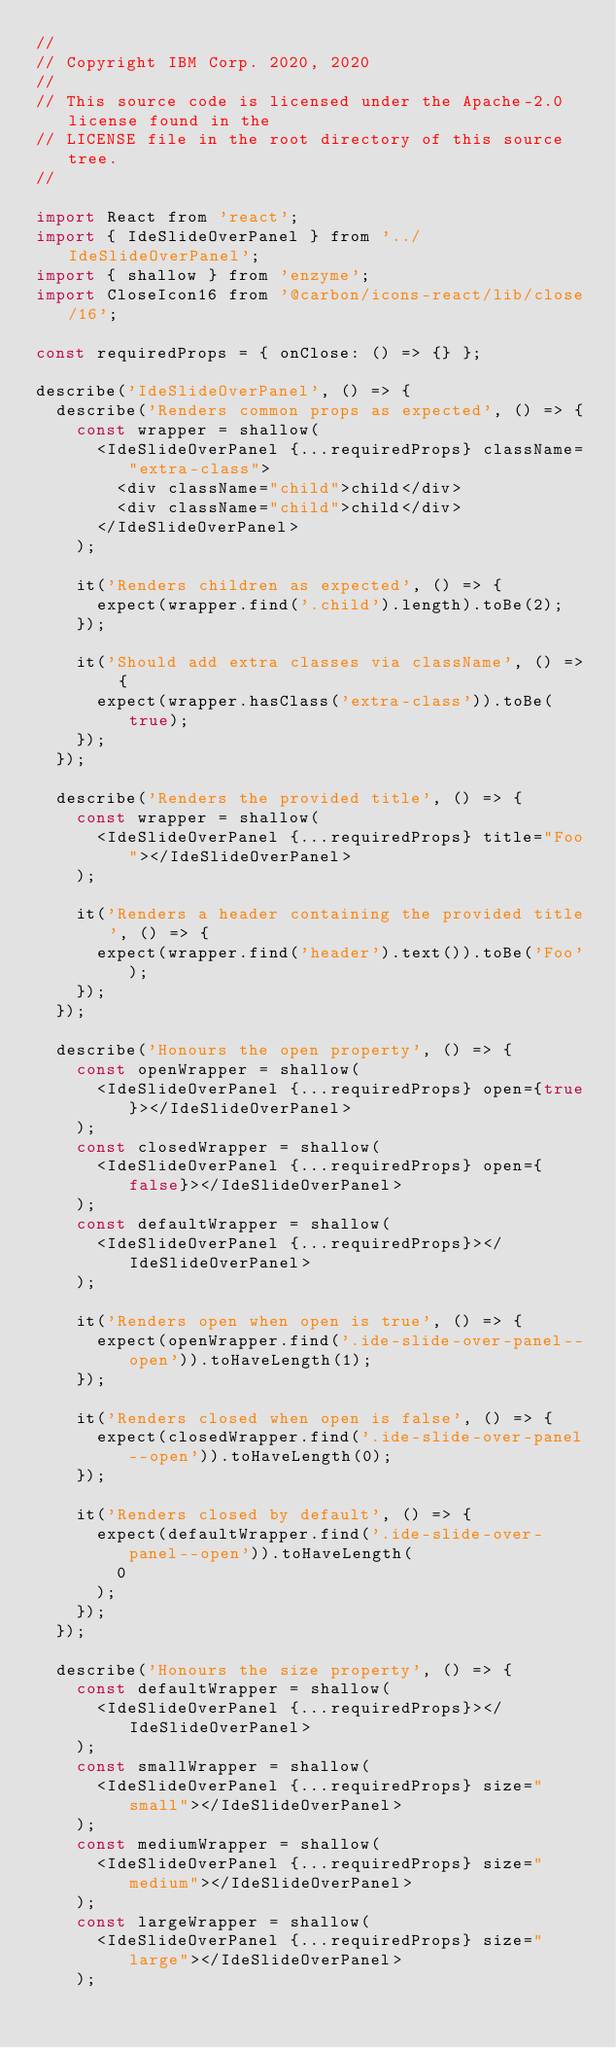Convert code to text. <code><loc_0><loc_0><loc_500><loc_500><_JavaScript_>//
// Copyright IBM Corp. 2020, 2020
//
// This source code is licensed under the Apache-2.0 license found in the
// LICENSE file in the root directory of this source tree.
//

import React from 'react';
import { IdeSlideOverPanel } from '../IdeSlideOverPanel';
import { shallow } from 'enzyme';
import CloseIcon16 from '@carbon/icons-react/lib/close/16';

const requiredProps = { onClose: () => {} };

describe('IdeSlideOverPanel', () => {
  describe('Renders common props as expected', () => {
    const wrapper = shallow(
      <IdeSlideOverPanel {...requiredProps} className="extra-class">
        <div className="child">child</div>
        <div className="child">child</div>
      </IdeSlideOverPanel>
    );

    it('Renders children as expected', () => {
      expect(wrapper.find('.child').length).toBe(2);
    });

    it('Should add extra classes via className', () => {
      expect(wrapper.hasClass('extra-class')).toBe(true);
    });
  });

  describe('Renders the provided title', () => {
    const wrapper = shallow(
      <IdeSlideOverPanel {...requiredProps} title="Foo"></IdeSlideOverPanel>
    );

    it('Renders a header containing the provided title', () => {
      expect(wrapper.find('header').text()).toBe('Foo');
    });
  });

  describe('Honours the open property', () => {
    const openWrapper = shallow(
      <IdeSlideOverPanel {...requiredProps} open={true}></IdeSlideOverPanel>
    );
    const closedWrapper = shallow(
      <IdeSlideOverPanel {...requiredProps} open={false}></IdeSlideOverPanel>
    );
    const defaultWrapper = shallow(
      <IdeSlideOverPanel {...requiredProps}></IdeSlideOverPanel>
    );

    it('Renders open when open is true', () => {
      expect(openWrapper.find('.ide-slide-over-panel--open')).toHaveLength(1);
    });

    it('Renders closed when open is false', () => {
      expect(closedWrapper.find('.ide-slide-over-panel--open')).toHaveLength(0);
    });

    it('Renders closed by default', () => {
      expect(defaultWrapper.find('.ide-slide-over-panel--open')).toHaveLength(
        0
      );
    });
  });

  describe('Honours the size property', () => {
    const defaultWrapper = shallow(
      <IdeSlideOverPanel {...requiredProps}></IdeSlideOverPanel>
    );
    const smallWrapper = shallow(
      <IdeSlideOverPanel {...requiredProps} size="small"></IdeSlideOverPanel>
    );
    const mediumWrapper = shallow(
      <IdeSlideOverPanel {...requiredProps} size="medium"></IdeSlideOverPanel>
    );
    const largeWrapper = shallow(
      <IdeSlideOverPanel {...requiredProps} size="large"></IdeSlideOverPanel>
    );
</code> 